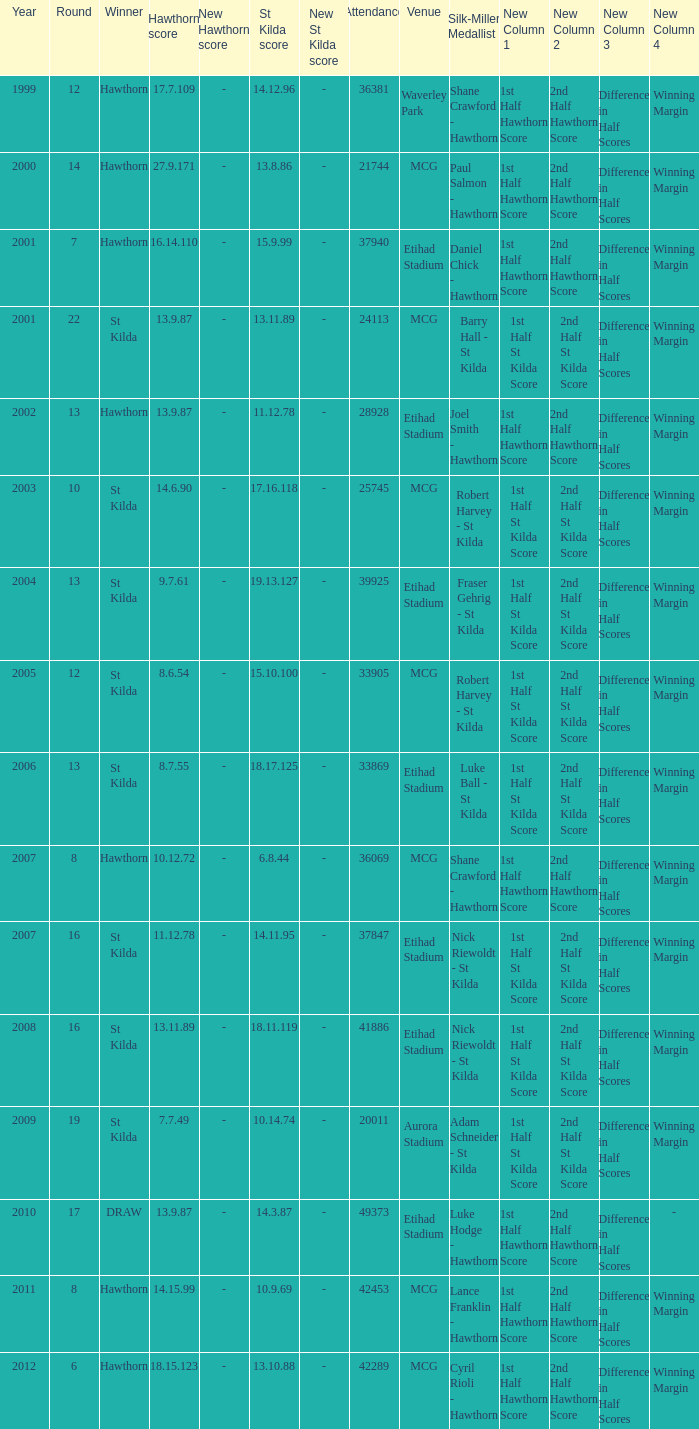What is the attendance when the st kilda score is 13.10.88? 42289.0. 